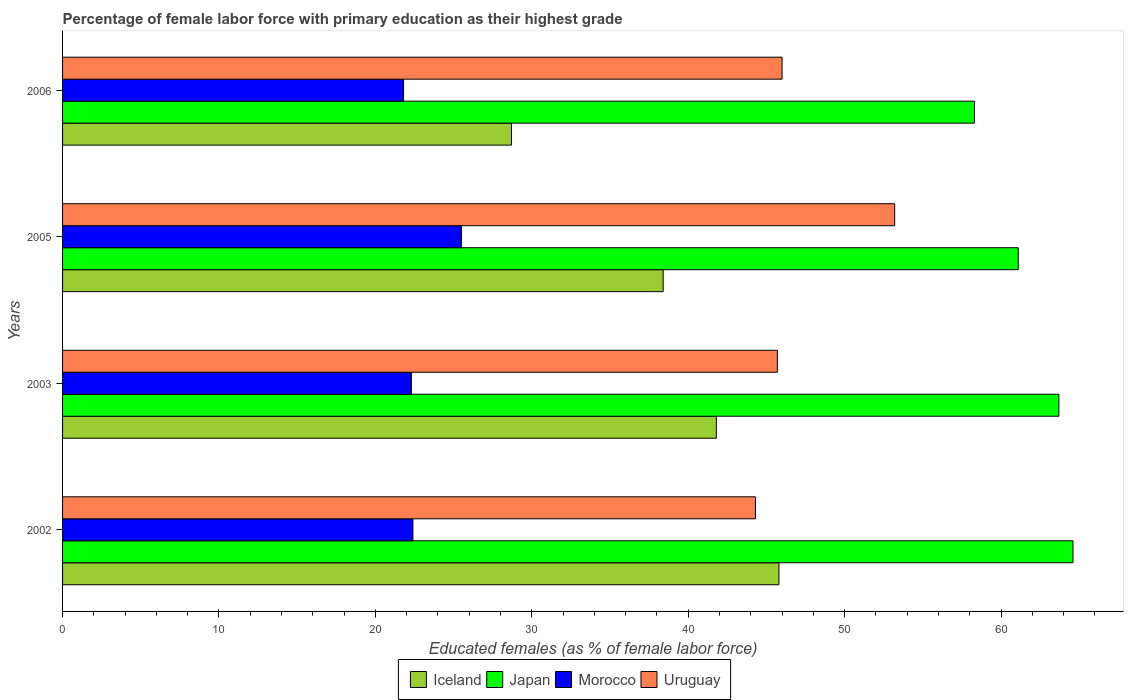How many different coloured bars are there?
Ensure brevity in your answer.  4. How many groups of bars are there?
Your answer should be very brief. 4. How many bars are there on the 3rd tick from the top?
Make the answer very short. 4. How many bars are there on the 2nd tick from the bottom?
Provide a short and direct response. 4. In how many cases, is the number of bars for a given year not equal to the number of legend labels?
Make the answer very short. 0. What is the percentage of female labor force with primary education in Japan in 2006?
Provide a short and direct response. 58.3. Across all years, what is the maximum percentage of female labor force with primary education in Uruguay?
Your response must be concise. 53.2. Across all years, what is the minimum percentage of female labor force with primary education in Japan?
Provide a short and direct response. 58.3. What is the total percentage of female labor force with primary education in Iceland in the graph?
Make the answer very short. 154.7. What is the difference between the percentage of female labor force with primary education in Iceland in 2003 and that in 2005?
Provide a succinct answer. 3.4. What is the average percentage of female labor force with primary education in Morocco per year?
Your response must be concise. 23. In the year 2006, what is the difference between the percentage of female labor force with primary education in Morocco and percentage of female labor force with primary education in Japan?
Offer a terse response. -36.5. What is the ratio of the percentage of female labor force with primary education in Uruguay in 2002 to that in 2005?
Ensure brevity in your answer.  0.83. Is the difference between the percentage of female labor force with primary education in Morocco in 2005 and 2006 greater than the difference between the percentage of female labor force with primary education in Japan in 2005 and 2006?
Offer a terse response. Yes. What is the difference between the highest and the second highest percentage of female labor force with primary education in Japan?
Offer a terse response. 0.9. What is the difference between the highest and the lowest percentage of female labor force with primary education in Morocco?
Make the answer very short. 3.7. Is the sum of the percentage of female labor force with primary education in Uruguay in 2005 and 2006 greater than the maximum percentage of female labor force with primary education in Morocco across all years?
Your response must be concise. Yes. What does the 2nd bar from the top in 2002 represents?
Your answer should be very brief. Morocco. What does the 2nd bar from the bottom in 2006 represents?
Make the answer very short. Japan. Is it the case that in every year, the sum of the percentage of female labor force with primary education in Japan and percentage of female labor force with primary education in Uruguay is greater than the percentage of female labor force with primary education in Iceland?
Your response must be concise. Yes. How many bars are there?
Make the answer very short. 16. Does the graph contain any zero values?
Make the answer very short. No. How many legend labels are there?
Your response must be concise. 4. What is the title of the graph?
Provide a succinct answer. Percentage of female labor force with primary education as their highest grade. Does "Armenia" appear as one of the legend labels in the graph?
Give a very brief answer. No. What is the label or title of the X-axis?
Your answer should be compact. Educated females (as % of female labor force). What is the Educated females (as % of female labor force) of Iceland in 2002?
Give a very brief answer. 45.8. What is the Educated females (as % of female labor force) of Japan in 2002?
Offer a terse response. 64.6. What is the Educated females (as % of female labor force) in Morocco in 2002?
Your answer should be very brief. 22.4. What is the Educated females (as % of female labor force) of Uruguay in 2002?
Make the answer very short. 44.3. What is the Educated females (as % of female labor force) of Iceland in 2003?
Provide a short and direct response. 41.8. What is the Educated females (as % of female labor force) in Japan in 2003?
Give a very brief answer. 63.7. What is the Educated females (as % of female labor force) in Morocco in 2003?
Give a very brief answer. 22.3. What is the Educated females (as % of female labor force) in Uruguay in 2003?
Make the answer very short. 45.7. What is the Educated females (as % of female labor force) of Iceland in 2005?
Your response must be concise. 38.4. What is the Educated females (as % of female labor force) in Japan in 2005?
Make the answer very short. 61.1. What is the Educated females (as % of female labor force) of Uruguay in 2005?
Offer a very short reply. 53.2. What is the Educated females (as % of female labor force) of Iceland in 2006?
Give a very brief answer. 28.7. What is the Educated females (as % of female labor force) in Japan in 2006?
Your answer should be very brief. 58.3. What is the Educated females (as % of female labor force) of Morocco in 2006?
Give a very brief answer. 21.8. What is the Educated females (as % of female labor force) in Uruguay in 2006?
Give a very brief answer. 46. Across all years, what is the maximum Educated females (as % of female labor force) in Iceland?
Keep it short and to the point. 45.8. Across all years, what is the maximum Educated females (as % of female labor force) in Japan?
Give a very brief answer. 64.6. Across all years, what is the maximum Educated females (as % of female labor force) in Morocco?
Provide a succinct answer. 25.5. Across all years, what is the maximum Educated females (as % of female labor force) in Uruguay?
Make the answer very short. 53.2. Across all years, what is the minimum Educated females (as % of female labor force) in Iceland?
Your answer should be compact. 28.7. Across all years, what is the minimum Educated females (as % of female labor force) in Japan?
Keep it short and to the point. 58.3. Across all years, what is the minimum Educated females (as % of female labor force) in Morocco?
Provide a succinct answer. 21.8. Across all years, what is the minimum Educated females (as % of female labor force) of Uruguay?
Your response must be concise. 44.3. What is the total Educated females (as % of female labor force) in Iceland in the graph?
Your answer should be very brief. 154.7. What is the total Educated females (as % of female labor force) in Japan in the graph?
Offer a terse response. 247.7. What is the total Educated females (as % of female labor force) in Morocco in the graph?
Keep it short and to the point. 92. What is the total Educated females (as % of female labor force) in Uruguay in the graph?
Offer a terse response. 189.2. What is the difference between the Educated females (as % of female labor force) of Morocco in 2002 and that in 2003?
Give a very brief answer. 0.1. What is the difference between the Educated females (as % of female labor force) of Morocco in 2002 and that in 2005?
Keep it short and to the point. -3.1. What is the difference between the Educated females (as % of female labor force) in Uruguay in 2002 and that in 2005?
Provide a succinct answer. -8.9. What is the difference between the Educated females (as % of female labor force) of Iceland in 2002 and that in 2006?
Give a very brief answer. 17.1. What is the difference between the Educated females (as % of female labor force) of Japan in 2002 and that in 2006?
Give a very brief answer. 6.3. What is the difference between the Educated females (as % of female labor force) of Morocco in 2002 and that in 2006?
Your answer should be compact. 0.6. What is the difference between the Educated females (as % of female labor force) of Uruguay in 2002 and that in 2006?
Make the answer very short. -1.7. What is the difference between the Educated females (as % of female labor force) in Iceland in 2003 and that in 2005?
Provide a succinct answer. 3.4. What is the difference between the Educated females (as % of female labor force) of Morocco in 2003 and that in 2005?
Offer a very short reply. -3.2. What is the difference between the Educated females (as % of female labor force) in Iceland in 2003 and that in 2006?
Offer a very short reply. 13.1. What is the difference between the Educated females (as % of female labor force) of Uruguay in 2003 and that in 2006?
Give a very brief answer. -0.3. What is the difference between the Educated females (as % of female labor force) of Iceland in 2005 and that in 2006?
Make the answer very short. 9.7. What is the difference between the Educated females (as % of female labor force) of Japan in 2005 and that in 2006?
Offer a terse response. 2.8. What is the difference between the Educated females (as % of female labor force) in Uruguay in 2005 and that in 2006?
Your response must be concise. 7.2. What is the difference between the Educated females (as % of female labor force) of Iceland in 2002 and the Educated females (as % of female labor force) of Japan in 2003?
Give a very brief answer. -17.9. What is the difference between the Educated females (as % of female labor force) of Japan in 2002 and the Educated females (as % of female labor force) of Morocco in 2003?
Offer a very short reply. 42.3. What is the difference between the Educated females (as % of female labor force) in Morocco in 2002 and the Educated females (as % of female labor force) in Uruguay in 2003?
Your answer should be very brief. -23.3. What is the difference between the Educated females (as % of female labor force) of Iceland in 2002 and the Educated females (as % of female labor force) of Japan in 2005?
Make the answer very short. -15.3. What is the difference between the Educated females (as % of female labor force) in Iceland in 2002 and the Educated females (as % of female labor force) in Morocco in 2005?
Your answer should be compact. 20.3. What is the difference between the Educated females (as % of female labor force) in Iceland in 2002 and the Educated females (as % of female labor force) in Uruguay in 2005?
Your answer should be compact. -7.4. What is the difference between the Educated females (as % of female labor force) in Japan in 2002 and the Educated females (as % of female labor force) in Morocco in 2005?
Keep it short and to the point. 39.1. What is the difference between the Educated females (as % of female labor force) in Morocco in 2002 and the Educated females (as % of female labor force) in Uruguay in 2005?
Provide a short and direct response. -30.8. What is the difference between the Educated females (as % of female labor force) of Iceland in 2002 and the Educated females (as % of female labor force) of Japan in 2006?
Give a very brief answer. -12.5. What is the difference between the Educated females (as % of female labor force) in Iceland in 2002 and the Educated females (as % of female labor force) in Morocco in 2006?
Your response must be concise. 24. What is the difference between the Educated females (as % of female labor force) in Japan in 2002 and the Educated females (as % of female labor force) in Morocco in 2006?
Ensure brevity in your answer.  42.8. What is the difference between the Educated females (as % of female labor force) in Morocco in 2002 and the Educated females (as % of female labor force) in Uruguay in 2006?
Your response must be concise. -23.6. What is the difference between the Educated females (as % of female labor force) of Iceland in 2003 and the Educated females (as % of female labor force) of Japan in 2005?
Your response must be concise. -19.3. What is the difference between the Educated females (as % of female labor force) in Iceland in 2003 and the Educated females (as % of female labor force) in Uruguay in 2005?
Provide a short and direct response. -11.4. What is the difference between the Educated females (as % of female labor force) of Japan in 2003 and the Educated females (as % of female labor force) of Morocco in 2005?
Make the answer very short. 38.2. What is the difference between the Educated females (as % of female labor force) of Morocco in 2003 and the Educated females (as % of female labor force) of Uruguay in 2005?
Make the answer very short. -30.9. What is the difference between the Educated females (as % of female labor force) in Iceland in 2003 and the Educated females (as % of female labor force) in Japan in 2006?
Make the answer very short. -16.5. What is the difference between the Educated females (as % of female labor force) of Japan in 2003 and the Educated females (as % of female labor force) of Morocco in 2006?
Offer a terse response. 41.9. What is the difference between the Educated females (as % of female labor force) of Japan in 2003 and the Educated females (as % of female labor force) of Uruguay in 2006?
Your response must be concise. 17.7. What is the difference between the Educated females (as % of female labor force) of Morocco in 2003 and the Educated females (as % of female labor force) of Uruguay in 2006?
Offer a terse response. -23.7. What is the difference between the Educated females (as % of female labor force) of Iceland in 2005 and the Educated females (as % of female labor force) of Japan in 2006?
Ensure brevity in your answer.  -19.9. What is the difference between the Educated females (as % of female labor force) of Iceland in 2005 and the Educated females (as % of female labor force) of Uruguay in 2006?
Offer a very short reply. -7.6. What is the difference between the Educated females (as % of female labor force) in Japan in 2005 and the Educated females (as % of female labor force) in Morocco in 2006?
Offer a very short reply. 39.3. What is the difference between the Educated females (as % of female labor force) of Morocco in 2005 and the Educated females (as % of female labor force) of Uruguay in 2006?
Provide a short and direct response. -20.5. What is the average Educated females (as % of female labor force) in Iceland per year?
Offer a terse response. 38.67. What is the average Educated females (as % of female labor force) in Japan per year?
Give a very brief answer. 61.92. What is the average Educated females (as % of female labor force) of Morocco per year?
Ensure brevity in your answer.  23. What is the average Educated females (as % of female labor force) in Uruguay per year?
Keep it short and to the point. 47.3. In the year 2002, what is the difference between the Educated females (as % of female labor force) in Iceland and Educated females (as % of female labor force) in Japan?
Offer a very short reply. -18.8. In the year 2002, what is the difference between the Educated females (as % of female labor force) in Iceland and Educated females (as % of female labor force) in Morocco?
Your answer should be very brief. 23.4. In the year 2002, what is the difference between the Educated females (as % of female labor force) in Iceland and Educated females (as % of female labor force) in Uruguay?
Keep it short and to the point. 1.5. In the year 2002, what is the difference between the Educated females (as % of female labor force) of Japan and Educated females (as % of female labor force) of Morocco?
Provide a succinct answer. 42.2. In the year 2002, what is the difference between the Educated females (as % of female labor force) of Japan and Educated females (as % of female labor force) of Uruguay?
Ensure brevity in your answer.  20.3. In the year 2002, what is the difference between the Educated females (as % of female labor force) in Morocco and Educated females (as % of female labor force) in Uruguay?
Your answer should be compact. -21.9. In the year 2003, what is the difference between the Educated females (as % of female labor force) in Iceland and Educated females (as % of female labor force) in Japan?
Offer a very short reply. -21.9. In the year 2003, what is the difference between the Educated females (as % of female labor force) in Japan and Educated females (as % of female labor force) in Morocco?
Provide a succinct answer. 41.4. In the year 2003, what is the difference between the Educated females (as % of female labor force) in Morocco and Educated females (as % of female labor force) in Uruguay?
Give a very brief answer. -23.4. In the year 2005, what is the difference between the Educated females (as % of female labor force) of Iceland and Educated females (as % of female labor force) of Japan?
Offer a very short reply. -22.7. In the year 2005, what is the difference between the Educated females (as % of female labor force) of Iceland and Educated females (as % of female labor force) of Uruguay?
Make the answer very short. -14.8. In the year 2005, what is the difference between the Educated females (as % of female labor force) in Japan and Educated females (as % of female labor force) in Morocco?
Keep it short and to the point. 35.6. In the year 2005, what is the difference between the Educated females (as % of female labor force) in Japan and Educated females (as % of female labor force) in Uruguay?
Your answer should be very brief. 7.9. In the year 2005, what is the difference between the Educated females (as % of female labor force) of Morocco and Educated females (as % of female labor force) of Uruguay?
Your answer should be very brief. -27.7. In the year 2006, what is the difference between the Educated females (as % of female labor force) of Iceland and Educated females (as % of female labor force) of Japan?
Your answer should be compact. -29.6. In the year 2006, what is the difference between the Educated females (as % of female labor force) in Iceland and Educated females (as % of female labor force) in Uruguay?
Your answer should be compact. -17.3. In the year 2006, what is the difference between the Educated females (as % of female labor force) in Japan and Educated females (as % of female labor force) in Morocco?
Offer a very short reply. 36.5. In the year 2006, what is the difference between the Educated females (as % of female labor force) of Morocco and Educated females (as % of female labor force) of Uruguay?
Your answer should be very brief. -24.2. What is the ratio of the Educated females (as % of female labor force) in Iceland in 2002 to that in 2003?
Keep it short and to the point. 1.1. What is the ratio of the Educated females (as % of female labor force) of Japan in 2002 to that in 2003?
Offer a terse response. 1.01. What is the ratio of the Educated females (as % of female labor force) of Morocco in 2002 to that in 2003?
Give a very brief answer. 1. What is the ratio of the Educated females (as % of female labor force) of Uruguay in 2002 to that in 2003?
Offer a very short reply. 0.97. What is the ratio of the Educated females (as % of female labor force) of Iceland in 2002 to that in 2005?
Give a very brief answer. 1.19. What is the ratio of the Educated females (as % of female labor force) of Japan in 2002 to that in 2005?
Provide a short and direct response. 1.06. What is the ratio of the Educated females (as % of female labor force) in Morocco in 2002 to that in 2005?
Offer a very short reply. 0.88. What is the ratio of the Educated females (as % of female labor force) of Uruguay in 2002 to that in 2005?
Your response must be concise. 0.83. What is the ratio of the Educated females (as % of female labor force) in Iceland in 2002 to that in 2006?
Your answer should be compact. 1.6. What is the ratio of the Educated females (as % of female labor force) in Japan in 2002 to that in 2006?
Your answer should be compact. 1.11. What is the ratio of the Educated females (as % of female labor force) in Morocco in 2002 to that in 2006?
Make the answer very short. 1.03. What is the ratio of the Educated females (as % of female labor force) in Iceland in 2003 to that in 2005?
Your answer should be very brief. 1.09. What is the ratio of the Educated females (as % of female labor force) of Japan in 2003 to that in 2005?
Provide a short and direct response. 1.04. What is the ratio of the Educated females (as % of female labor force) in Morocco in 2003 to that in 2005?
Ensure brevity in your answer.  0.87. What is the ratio of the Educated females (as % of female labor force) in Uruguay in 2003 to that in 2005?
Ensure brevity in your answer.  0.86. What is the ratio of the Educated females (as % of female labor force) in Iceland in 2003 to that in 2006?
Your answer should be very brief. 1.46. What is the ratio of the Educated females (as % of female labor force) of Japan in 2003 to that in 2006?
Offer a terse response. 1.09. What is the ratio of the Educated females (as % of female labor force) of Morocco in 2003 to that in 2006?
Provide a succinct answer. 1.02. What is the ratio of the Educated females (as % of female labor force) of Uruguay in 2003 to that in 2006?
Give a very brief answer. 0.99. What is the ratio of the Educated females (as % of female labor force) of Iceland in 2005 to that in 2006?
Offer a very short reply. 1.34. What is the ratio of the Educated females (as % of female labor force) of Japan in 2005 to that in 2006?
Provide a succinct answer. 1.05. What is the ratio of the Educated females (as % of female labor force) of Morocco in 2005 to that in 2006?
Ensure brevity in your answer.  1.17. What is the ratio of the Educated females (as % of female labor force) in Uruguay in 2005 to that in 2006?
Ensure brevity in your answer.  1.16. What is the difference between the highest and the second highest Educated females (as % of female labor force) of Iceland?
Your answer should be compact. 4. What is the difference between the highest and the second highest Educated females (as % of female labor force) in Japan?
Ensure brevity in your answer.  0.9. What is the difference between the highest and the second highest Educated females (as % of female labor force) of Morocco?
Your answer should be compact. 3.1. What is the difference between the highest and the lowest Educated females (as % of female labor force) of Morocco?
Offer a terse response. 3.7. What is the difference between the highest and the lowest Educated females (as % of female labor force) of Uruguay?
Provide a short and direct response. 8.9. 